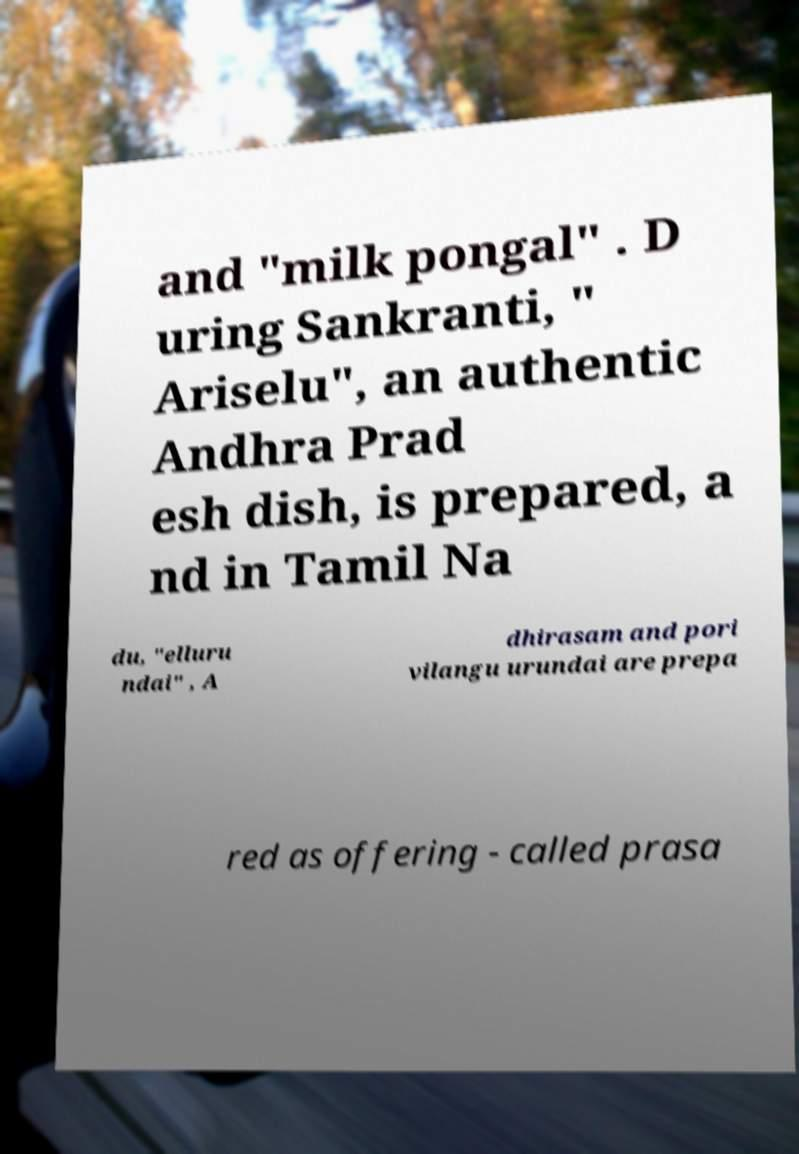Could you extract and type out the text from this image? and "milk pongal" . D uring Sankranti, " Ariselu", an authentic Andhra Prad esh dish, is prepared, a nd in Tamil Na du, "elluru ndai" , A dhirasam and pori vilangu urundai are prepa red as offering - called prasa 